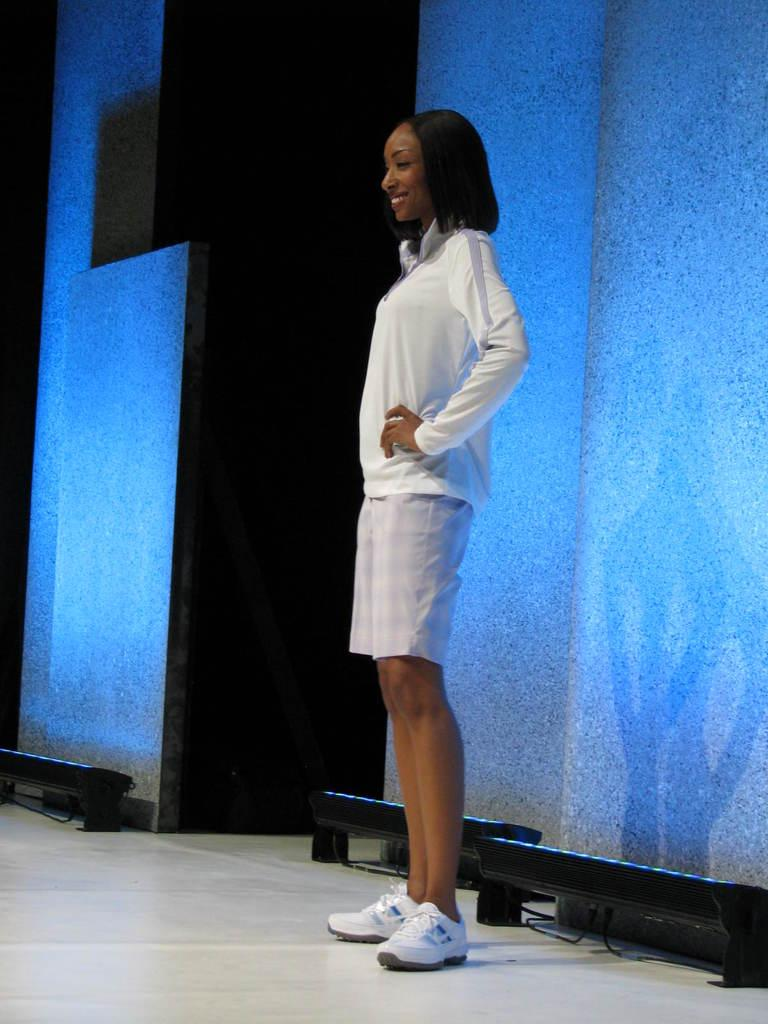Who is present in the image? There is a woman in the image. What is the woman doing in the image? The woman is standing on a white floor and smiling. What can be seen in the background of the image? There are boards, lights, and additional lights visible in the background. How would you describe the lighting conditions in the background? The background view is dark, with lights providing illumination. What type of tree can be seen in the image? There is no tree present in the image. What subject is being taught in the class depicted in the image? There is no class or subject being taught in the image; it features a woman standing on a white floor and smiling. 